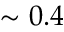Convert formula to latex. <formula><loc_0><loc_0><loc_500><loc_500>\sim 0 . 4</formula> 